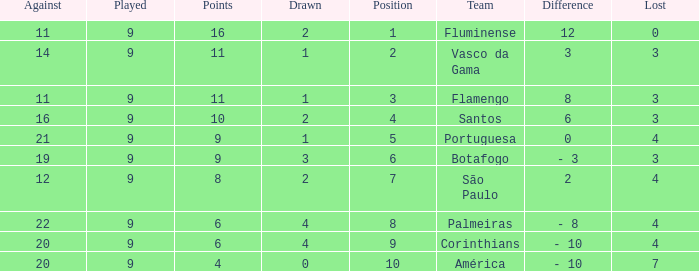Which Position has a Played larger than 9? None. 